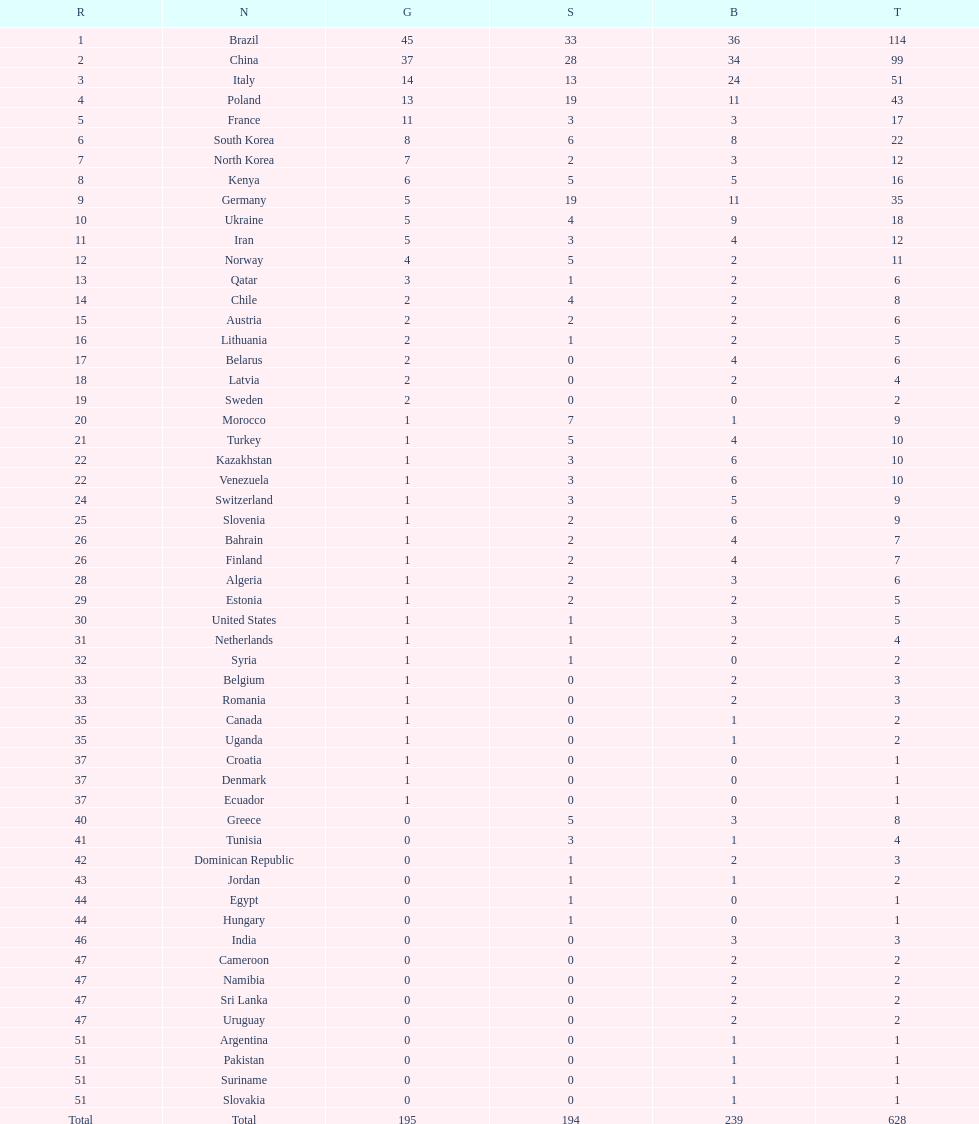South korea has how many more medals that north korea? 10. 